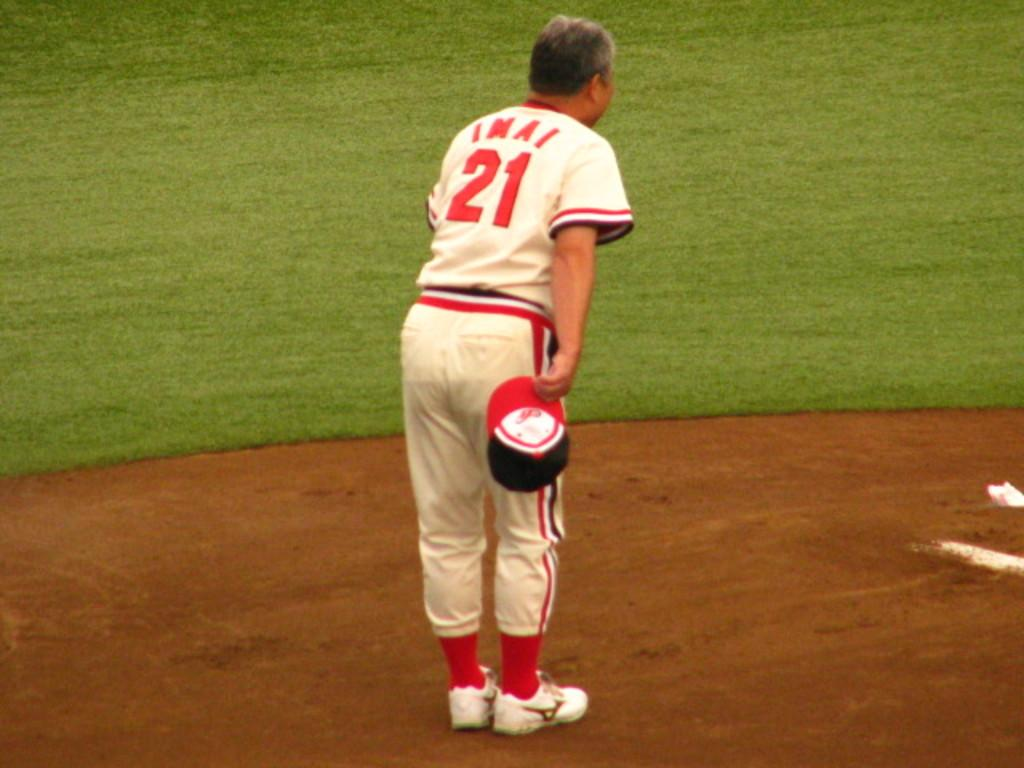<image>
Relay a brief, clear account of the picture shown. s man with the number 21 on his jersey 